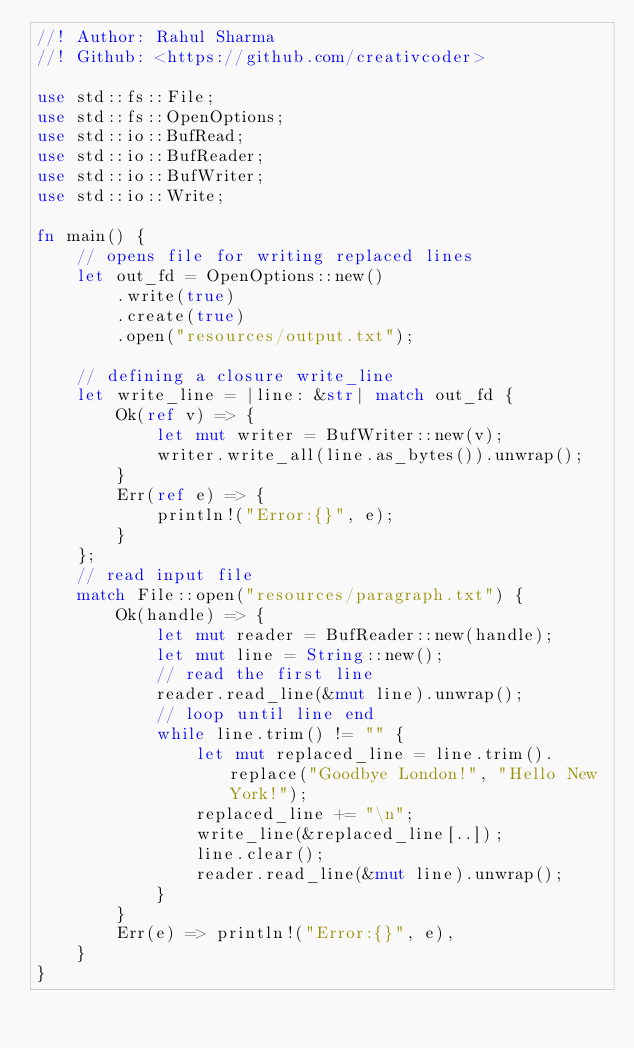Convert code to text. <code><loc_0><loc_0><loc_500><loc_500><_Rust_>//! Author: Rahul Sharma
//! Github: <https://github.com/creativcoder>

use std::fs::File;
use std::fs::OpenOptions;
use std::io::BufRead;
use std::io::BufReader;
use std::io::BufWriter;
use std::io::Write;

fn main() {
    // opens file for writing replaced lines
    let out_fd = OpenOptions::new()
        .write(true)
        .create(true)
        .open("resources/output.txt");

    // defining a closure write_line
    let write_line = |line: &str| match out_fd {
        Ok(ref v) => {
            let mut writer = BufWriter::new(v);
            writer.write_all(line.as_bytes()).unwrap();
        }
        Err(ref e) => {
            println!("Error:{}", e);
        }
    };
    // read input file
    match File::open("resources/paragraph.txt") {
        Ok(handle) => {
            let mut reader = BufReader::new(handle);
            let mut line = String::new();
            // read the first line
            reader.read_line(&mut line).unwrap();
            // loop until line end
            while line.trim() != "" {
                let mut replaced_line = line.trim().replace("Goodbye London!", "Hello New York!");
                replaced_line += "\n";
                write_line(&replaced_line[..]);
                line.clear();
                reader.read_line(&mut line).unwrap();
            }
        }
        Err(e) => println!("Error:{}", e),
    }
}
</code> 